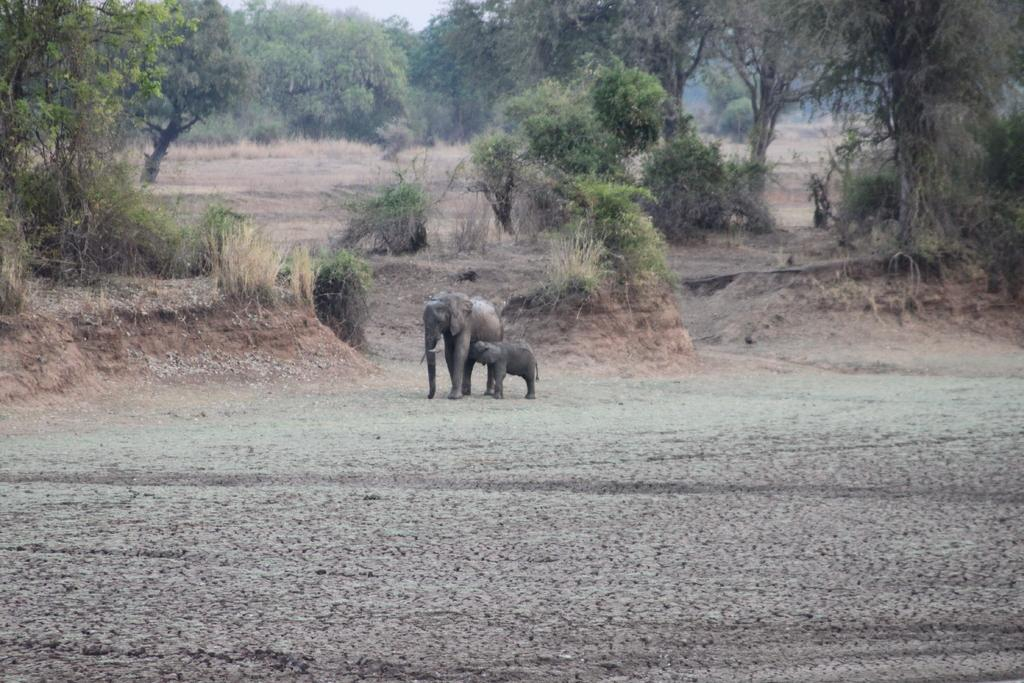How many elephants are present in the image? There are two elephants in the image. What are the elephants doing in the image? The elephants are standing on a surface. What can be seen in the background of the image? There are trees and the sky visible in the background of the image. What type of skin can be seen on the dime in the image? There is no dime present in the image, so it is not possible to determine the type of skin on it. 